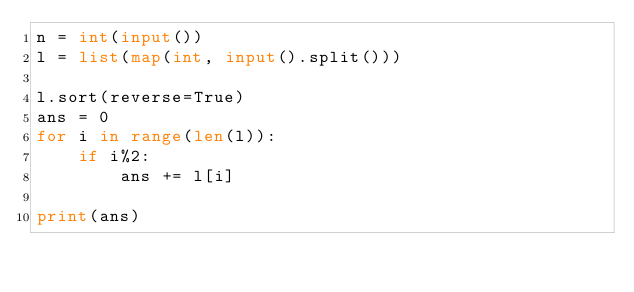Convert code to text. <code><loc_0><loc_0><loc_500><loc_500><_Python_>n = int(input())
l = list(map(int, input().split()))

l.sort(reverse=True)
ans = 0
for i in range(len(l)):
    if i%2:
        ans += l[i]

print(ans)
</code> 